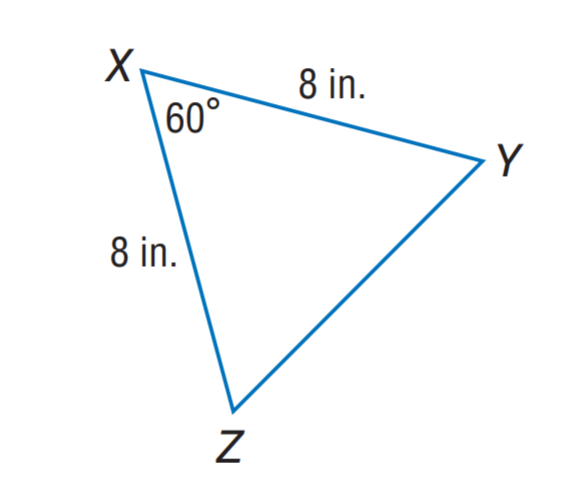Answer the mathemtical geometry problem and directly provide the correct option letter.
Question: Find m \angle Y.
Choices: A: 50 B: 60 C: 70 D: 80 B 